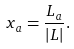Convert formula to latex. <formula><loc_0><loc_0><loc_500><loc_500>x _ { a } = \frac { L _ { a } } { | L | } .</formula> 